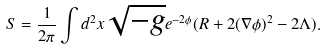Convert formula to latex. <formula><loc_0><loc_0><loc_500><loc_500>S = \frac { 1 } { 2 \pi } \int d ^ { 2 } x \sqrt { - g } e ^ { - 2 \phi } ( R + 2 ( \nabla \phi ) ^ { 2 } - 2 \Lambda ) .</formula> 